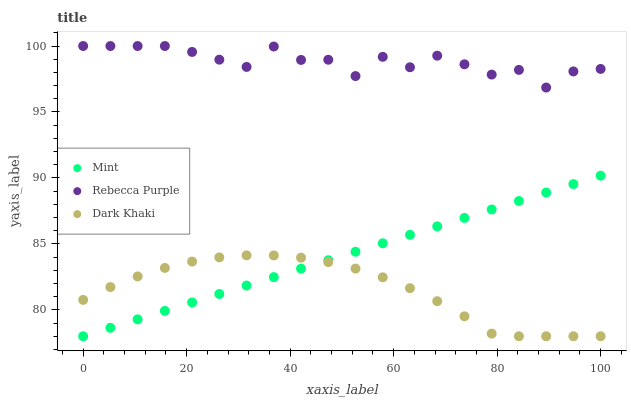Does Dark Khaki have the minimum area under the curve?
Answer yes or no. Yes. Does Rebecca Purple have the maximum area under the curve?
Answer yes or no. Yes. Does Mint have the minimum area under the curve?
Answer yes or no. No. Does Mint have the maximum area under the curve?
Answer yes or no. No. Is Mint the smoothest?
Answer yes or no. Yes. Is Rebecca Purple the roughest?
Answer yes or no. Yes. Is Rebecca Purple the smoothest?
Answer yes or no. No. Is Mint the roughest?
Answer yes or no. No. Does Dark Khaki have the lowest value?
Answer yes or no. Yes. Does Rebecca Purple have the lowest value?
Answer yes or no. No. Does Rebecca Purple have the highest value?
Answer yes or no. Yes. Does Mint have the highest value?
Answer yes or no. No. Is Dark Khaki less than Rebecca Purple?
Answer yes or no. Yes. Is Rebecca Purple greater than Dark Khaki?
Answer yes or no. Yes. Does Mint intersect Dark Khaki?
Answer yes or no. Yes. Is Mint less than Dark Khaki?
Answer yes or no. No. Is Mint greater than Dark Khaki?
Answer yes or no. No. Does Dark Khaki intersect Rebecca Purple?
Answer yes or no. No. 